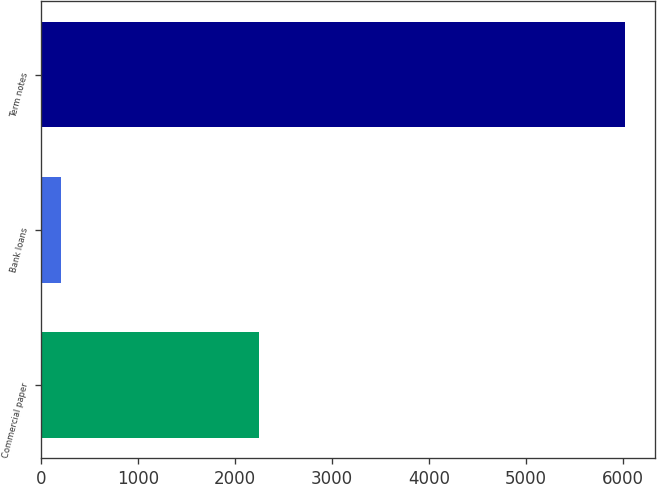<chart> <loc_0><loc_0><loc_500><loc_500><bar_chart><fcel>Commercial paper<fcel>Bank loans<fcel>Term notes<nl><fcel>2242.5<fcel>205<fcel>6027.7<nl></chart> 